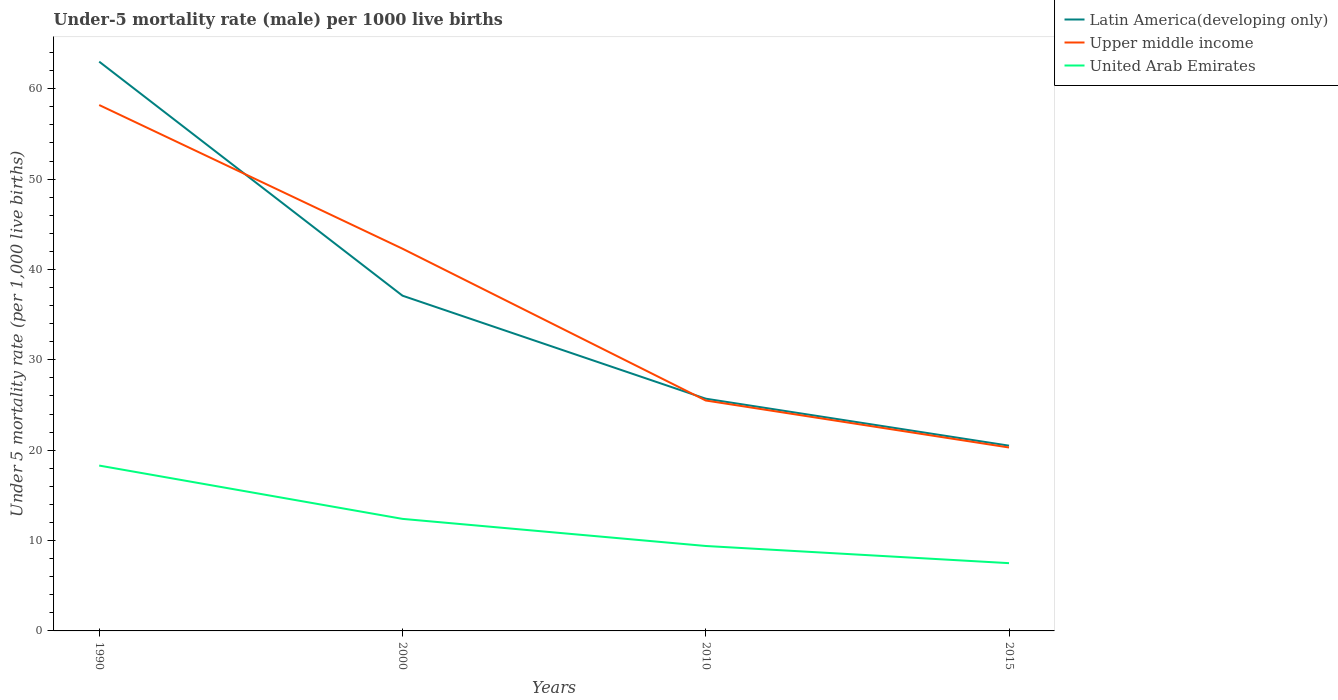How many different coloured lines are there?
Give a very brief answer. 3. Does the line corresponding to United Arab Emirates intersect with the line corresponding to Latin America(developing only)?
Offer a terse response. No. Is the number of lines equal to the number of legend labels?
Offer a very short reply. Yes. Across all years, what is the maximum under-five mortality rate in Upper middle income?
Your answer should be very brief. 20.3. In which year was the under-five mortality rate in United Arab Emirates maximum?
Provide a short and direct response. 2015. What is the total under-five mortality rate in Upper middle income in the graph?
Ensure brevity in your answer.  5.2. Is the under-five mortality rate in Latin America(developing only) strictly greater than the under-five mortality rate in Upper middle income over the years?
Your response must be concise. No. How many years are there in the graph?
Make the answer very short. 4. What is the difference between two consecutive major ticks on the Y-axis?
Keep it short and to the point. 10. Are the values on the major ticks of Y-axis written in scientific E-notation?
Provide a short and direct response. No. How are the legend labels stacked?
Give a very brief answer. Vertical. What is the title of the graph?
Your response must be concise. Under-5 mortality rate (male) per 1000 live births. Does "Hungary" appear as one of the legend labels in the graph?
Offer a very short reply. No. What is the label or title of the Y-axis?
Provide a succinct answer. Under 5 mortality rate (per 1,0 live births). What is the Under 5 mortality rate (per 1,000 live births) of Upper middle income in 1990?
Keep it short and to the point. 58.2. What is the Under 5 mortality rate (per 1,000 live births) in Latin America(developing only) in 2000?
Give a very brief answer. 37.1. What is the Under 5 mortality rate (per 1,000 live births) of Upper middle income in 2000?
Provide a succinct answer. 42.3. What is the Under 5 mortality rate (per 1,000 live births) of United Arab Emirates in 2000?
Keep it short and to the point. 12.4. What is the Under 5 mortality rate (per 1,000 live births) in Latin America(developing only) in 2010?
Your answer should be compact. 25.7. What is the Under 5 mortality rate (per 1,000 live births) of United Arab Emirates in 2010?
Offer a very short reply. 9.4. What is the Under 5 mortality rate (per 1,000 live births) in Latin America(developing only) in 2015?
Your response must be concise. 20.5. What is the Under 5 mortality rate (per 1,000 live births) in Upper middle income in 2015?
Provide a succinct answer. 20.3. Across all years, what is the maximum Under 5 mortality rate (per 1,000 live births) in Upper middle income?
Offer a terse response. 58.2. Across all years, what is the minimum Under 5 mortality rate (per 1,000 live births) of Latin America(developing only)?
Offer a terse response. 20.5. Across all years, what is the minimum Under 5 mortality rate (per 1,000 live births) in Upper middle income?
Make the answer very short. 20.3. Across all years, what is the minimum Under 5 mortality rate (per 1,000 live births) of United Arab Emirates?
Ensure brevity in your answer.  7.5. What is the total Under 5 mortality rate (per 1,000 live births) of Latin America(developing only) in the graph?
Your answer should be very brief. 146.3. What is the total Under 5 mortality rate (per 1,000 live births) in Upper middle income in the graph?
Your answer should be compact. 146.3. What is the total Under 5 mortality rate (per 1,000 live births) in United Arab Emirates in the graph?
Give a very brief answer. 47.6. What is the difference between the Under 5 mortality rate (per 1,000 live births) of Latin America(developing only) in 1990 and that in 2000?
Ensure brevity in your answer.  25.9. What is the difference between the Under 5 mortality rate (per 1,000 live births) in Latin America(developing only) in 1990 and that in 2010?
Provide a short and direct response. 37.3. What is the difference between the Under 5 mortality rate (per 1,000 live births) in Upper middle income in 1990 and that in 2010?
Keep it short and to the point. 32.7. What is the difference between the Under 5 mortality rate (per 1,000 live births) in Latin America(developing only) in 1990 and that in 2015?
Your response must be concise. 42.5. What is the difference between the Under 5 mortality rate (per 1,000 live births) of Upper middle income in 1990 and that in 2015?
Give a very brief answer. 37.9. What is the difference between the Under 5 mortality rate (per 1,000 live births) of Upper middle income in 2000 and that in 2010?
Offer a terse response. 16.8. What is the difference between the Under 5 mortality rate (per 1,000 live births) of United Arab Emirates in 2000 and that in 2010?
Provide a succinct answer. 3. What is the difference between the Under 5 mortality rate (per 1,000 live births) in Latin America(developing only) in 2000 and that in 2015?
Your answer should be compact. 16.6. What is the difference between the Under 5 mortality rate (per 1,000 live births) in United Arab Emirates in 2000 and that in 2015?
Your answer should be very brief. 4.9. What is the difference between the Under 5 mortality rate (per 1,000 live births) in Latin America(developing only) in 2010 and that in 2015?
Your answer should be compact. 5.2. What is the difference between the Under 5 mortality rate (per 1,000 live births) in Upper middle income in 2010 and that in 2015?
Ensure brevity in your answer.  5.2. What is the difference between the Under 5 mortality rate (per 1,000 live births) in United Arab Emirates in 2010 and that in 2015?
Ensure brevity in your answer.  1.9. What is the difference between the Under 5 mortality rate (per 1,000 live births) in Latin America(developing only) in 1990 and the Under 5 mortality rate (per 1,000 live births) in Upper middle income in 2000?
Offer a terse response. 20.7. What is the difference between the Under 5 mortality rate (per 1,000 live births) of Latin America(developing only) in 1990 and the Under 5 mortality rate (per 1,000 live births) of United Arab Emirates in 2000?
Provide a succinct answer. 50.6. What is the difference between the Under 5 mortality rate (per 1,000 live births) of Upper middle income in 1990 and the Under 5 mortality rate (per 1,000 live births) of United Arab Emirates in 2000?
Give a very brief answer. 45.8. What is the difference between the Under 5 mortality rate (per 1,000 live births) in Latin America(developing only) in 1990 and the Under 5 mortality rate (per 1,000 live births) in Upper middle income in 2010?
Give a very brief answer. 37.5. What is the difference between the Under 5 mortality rate (per 1,000 live births) in Latin America(developing only) in 1990 and the Under 5 mortality rate (per 1,000 live births) in United Arab Emirates in 2010?
Ensure brevity in your answer.  53.6. What is the difference between the Under 5 mortality rate (per 1,000 live births) in Upper middle income in 1990 and the Under 5 mortality rate (per 1,000 live births) in United Arab Emirates in 2010?
Your answer should be compact. 48.8. What is the difference between the Under 5 mortality rate (per 1,000 live births) in Latin America(developing only) in 1990 and the Under 5 mortality rate (per 1,000 live births) in Upper middle income in 2015?
Your response must be concise. 42.7. What is the difference between the Under 5 mortality rate (per 1,000 live births) in Latin America(developing only) in 1990 and the Under 5 mortality rate (per 1,000 live births) in United Arab Emirates in 2015?
Ensure brevity in your answer.  55.5. What is the difference between the Under 5 mortality rate (per 1,000 live births) of Upper middle income in 1990 and the Under 5 mortality rate (per 1,000 live births) of United Arab Emirates in 2015?
Ensure brevity in your answer.  50.7. What is the difference between the Under 5 mortality rate (per 1,000 live births) in Latin America(developing only) in 2000 and the Under 5 mortality rate (per 1,000 live births) in Upper middle income in 2010?
Your answer should be compact. 11.6. What is the difference between the Under 5 mortality rate (per 1,000 live births) of Latin America(developing only) in 2000 and the Under 5 mortality rate (per 1,000 live births) of United Arab Emirates in 2010?
Your answer should be compact. 27.7. What is the difference between the Under 5 mortality rate (per 1,000 live births) of Upper middle income in 2000 and the Under 5 mortality rate (per 1,000 live births) of United Arab Emirates in 2010?
Make the answer very short. 32.9. What is the difference between the Under 5 mortality rate (per 1,000 live births) in Latin America(developing only) in 2000 and the Under 5 mortality rate (per 1,000 live births) in United Arab Emirates in 2015?
Ensure brevity in your answer.  29.6. What is the difference between the Under 5 mortality rate (per 1,000 live births) of Upper middle income in 2000 and the Under 5 mortality rate (per 1,000 live births) of United Arab Emirates in 2015?
Your answer should be very brief. 34.8. What is the difference between the Under 5 mortality rate (per 1,000 live births) in Latin America(developing only) in 2010 and the Under 5 mortality rate (per 1,000 live births) in Upper middle income in 2015?
Offer a very short reply. 5.4. What is the difference between the Under 5 mortality rate (per 1,000 live births) of Latin America(developing only) in 2010 and the Under 5 mortality rate (per 1,000 live births) of United Arab Emirates in 2015?
Your answer should be very brief. 18.2. What is the average Under 5 mortality rate (per 1,000 live births) in Latin America(developing only) per year?
Your response must be concise. 36.58. What is the average Under 5 mortality rate (per 1,000 live births) in Upper middle income per year?
Keep it short and to the point. 36.58. In the year 1990, what is the difference between the Under 5 mortality rate (per 1,000 live births) in Latin America(developing only) and Under 5 mortality rate (per 1,000 live births) in United Arab Emirates?
Your response must be concise. 44.7. In the year 1990, what is the difference between the Under 5 mortality rate (per 1,000 live births) of Upper middle income and Under 5 mortality rate (per 1,000 live births) of United Arab Emirates?
Offer a terse response. 39.9. In the year 2000, what is the difference between the Under 5 mortality rate (per 1,000 live births) in Latin America(developing only) and Under 5 mortality rate (per 1,000 live births) in United Arab Emirates?
Your answer should be compact. 24.7. In the year 2000, what is the difference between the Under 5 mortality rate (per 1,000 live births) in Upper middle income and Under 5 mortality rate (per 1,000 live births) in United Arab Emirates?
Offer a very short reply. 29.9. In the year 2010, what is the difference between the Under 5 mortality rate (per 1,000 live births) of Latin America(developing only) and Under 5 mortality rate (per 1,000 live births) of Upper middle income?
Keep it short and to the point. 0.2. In the year 2015, what is the difference between the Under 5 mortality rate (per 1,000 live births) of Latin America(developing only) and Under 5 mortality rate (per 1,000 live births) of Upper middle income?
Offer a very short reply. 0.2. What is the ratio of the Under 5 mortality rate (per 1,000 live births) in Latin America(developing only) in 1990 to that in 2000?
Offer a very short reply. 1.7. What is the ratio of the Under 5 mortality rate (per 1,000 live births) of Upper middle income in 1990 to that in 2000?
Provide a succinct answer. 1.38. What is the ratio of the Under 5 mortality rate (per 1,000 live births) in United Arab Emirates in 1990 to that in 2000?
Offer a very short reply. 1.48. What is the ratio of the Under 5 mortality rate (per 1,000 live births) in Latin America(developing only) in 1990 to that in 2010?
Keep it short and to the point. 2.45. What is the ratio of the Under 5 mortality rate (per 1,000 live births) in Upper middle income in 1990 to that in 2010?
Ensure brevity in your answer.  2.28. What is the ratio of the Under 5 mortality rate (per 1,000 live births) in United Arab Emirates in 1990 to that in 2010?
Your answer should be compact. 1.95. What is the ratio of the Under 5 mortality rate (per 1,000 live births) of Latin America(developing only) in 1990 to that in 2015?
Provide a short and direct response. 3.07. What is the ratio of the Under 5 mortality rate (per 1,000 live births) in Upper middle income in 1990 to that in 2015?
Provide a short and direct response. 2.87. What is the ratio of the Under 5 mortality rate (per 1,000 live births) of United Arab Emirates in 1990 to that in 2015?
Provide a short and direct response. 2.44. What is the ratio of the Under 5 mortality rate (per 1,000 live births) in Latin America(developing only) in 2000 to that in 2010?
Ensure brevity in your answer.  1.44. What is the ratio of the Under 5 mortality rate (per 1,000 live births) in Upper middle income in 2000 to that in 2010?
Offer a very short reply. 1.66. What is the ratio of the Under 5 mortality rate (per 1,000 live births) in United Arab Emirates in 2000 to that in 2010?
Make the answer very short. 1.32. What is the ratio of the Under 5 mortality rate (per 1,000 live births) in Latin America(developing only) in 2000 to that in 2015?
Make the answer very short. 1.81. What is the ratio of the Under 5 mortality rate (per 1,000 live births) in Upper middle income in 2000 to that in 2015?
Provide a short and direct response. 2.08. What is the ratio of the Under 5 mortality rate (per 1,000 live births) of United Arab Emirates in 2000 to that in 2015?
Make the answer very short. 1.65. What is the ratio of the Under 5 mortality rate (per 1,000 live births) of Latin America(developing only) in 2010 to that in 2015?
Offer a terse response. 1.25. What is the ratio of the Under 5 mortality rate (per 1,000 live births) in Upper middle income in 2010 to that in 2015?
Ensure brevity in your answer.  1.26. What is the ratio of the Under 5 mortality rate (per 1,000 live births) of United Arab Emirates in 2010 to that in 2015?
Ensure brevity in your answer.  1.25. What is the difference between the highest and the second highest Under 5 mortality rate (per 1,000 live births) of Latin America(developing only)?
Your answer should be compact. 25.9. What is the difference between the highest and the second highest Under 5 mortality rate (per 1,000 live births) of Upper middle income?
Provide a short and direct response. 15.9. What is the difference between the highest and the lowest Under 5 mortality rate (per 1,000 live births) in Latin America(developing only)?
Provide a short and direct response. 42.5. What is the difference between the highest and the lowest Under 5 mortality rate (per 1,000 live births) in Upper middle income?
Give a very brief answer. 37.9. 